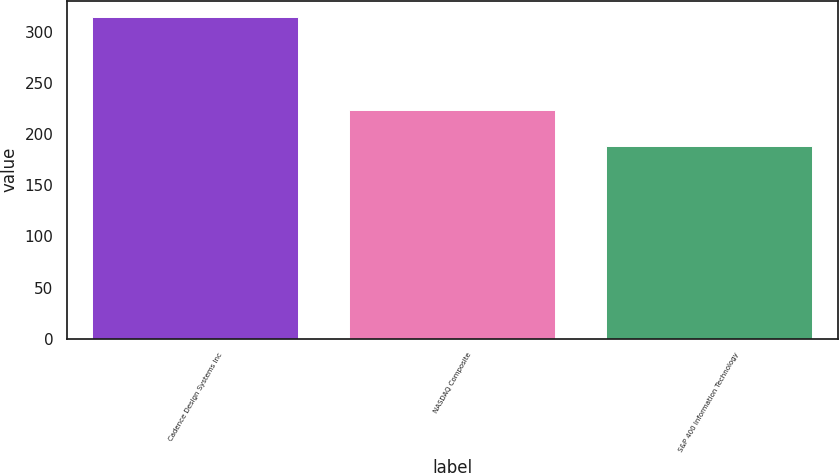<chart> <loc_0><loc_0><loc_500><loc_500><bar_chart><fcel>Cadence Design Systems Inc<fcel>NASDAQ Composite<fcel>S&P 400 Information Technology<nl><fcel>314.36<fcel>223.74<fcel>187.84<nl></chart> 